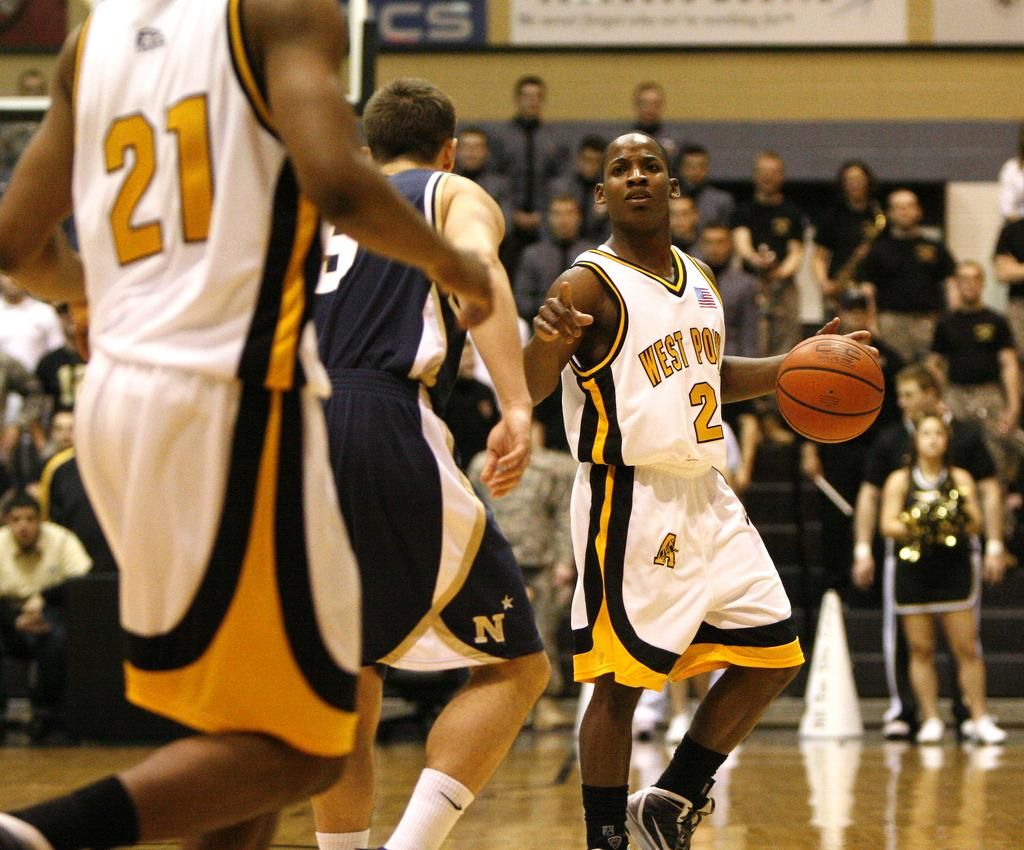<image>
Give a short and clear explanation of the subsequent image. Player number 2 currently has the basketball, and player 21 is nearby. 